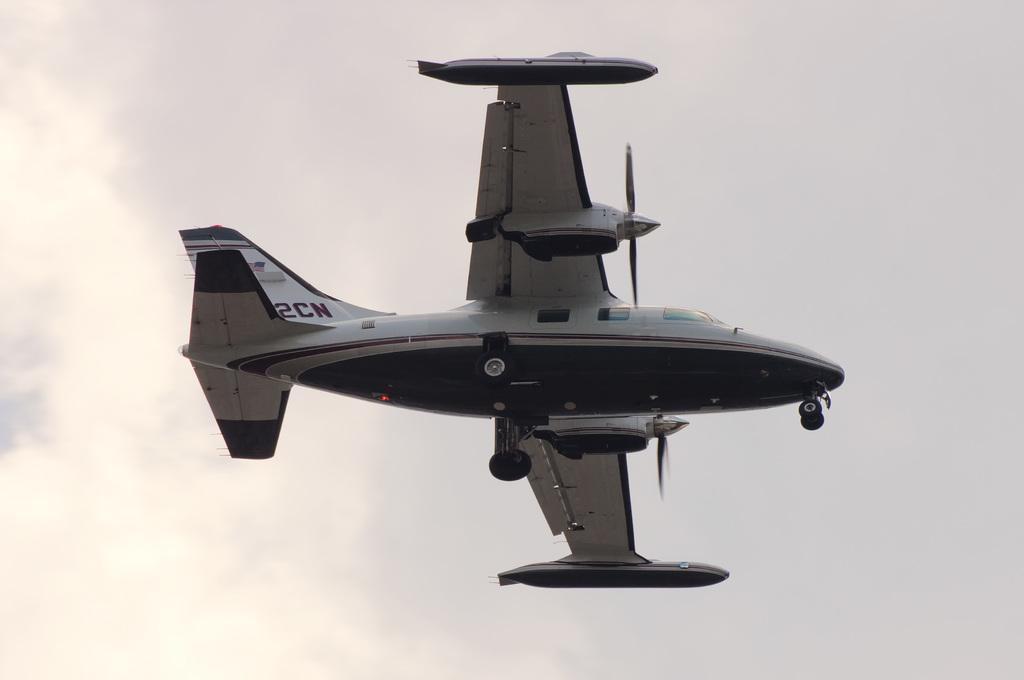Describe this image in one or two sentences. In this image there is an aircraft flying on a sky. And at the top there is a sky with clouds. 